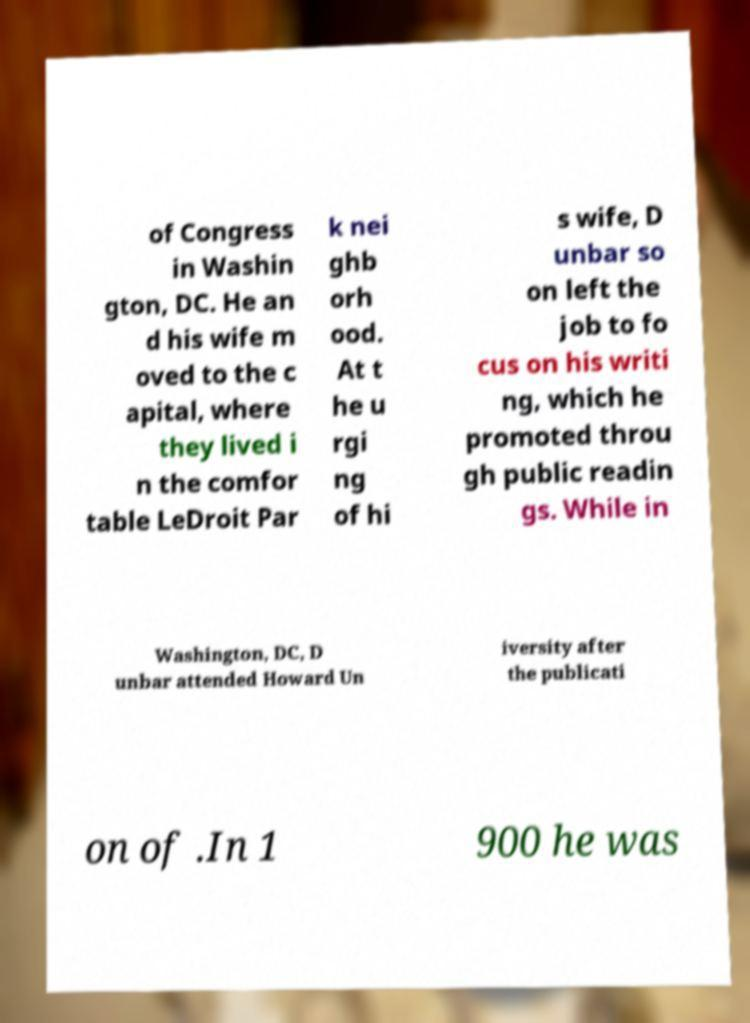Please read and relay the text visible in this image. What does it say? of Congress in Washin gton, DC. He an d his wife m oved to the c apital, where they lived i n the comfor table LeDroit Par k nei ghb orh ood. At t he u rgi ng of hi s wife, D unbar so on left the job to fo cus on his writi ng, which he promoted throu gh public readin gs. While in Washington, DC, D unbar attended Howard Un iversity after the publicati on of .In 1 900 he was 